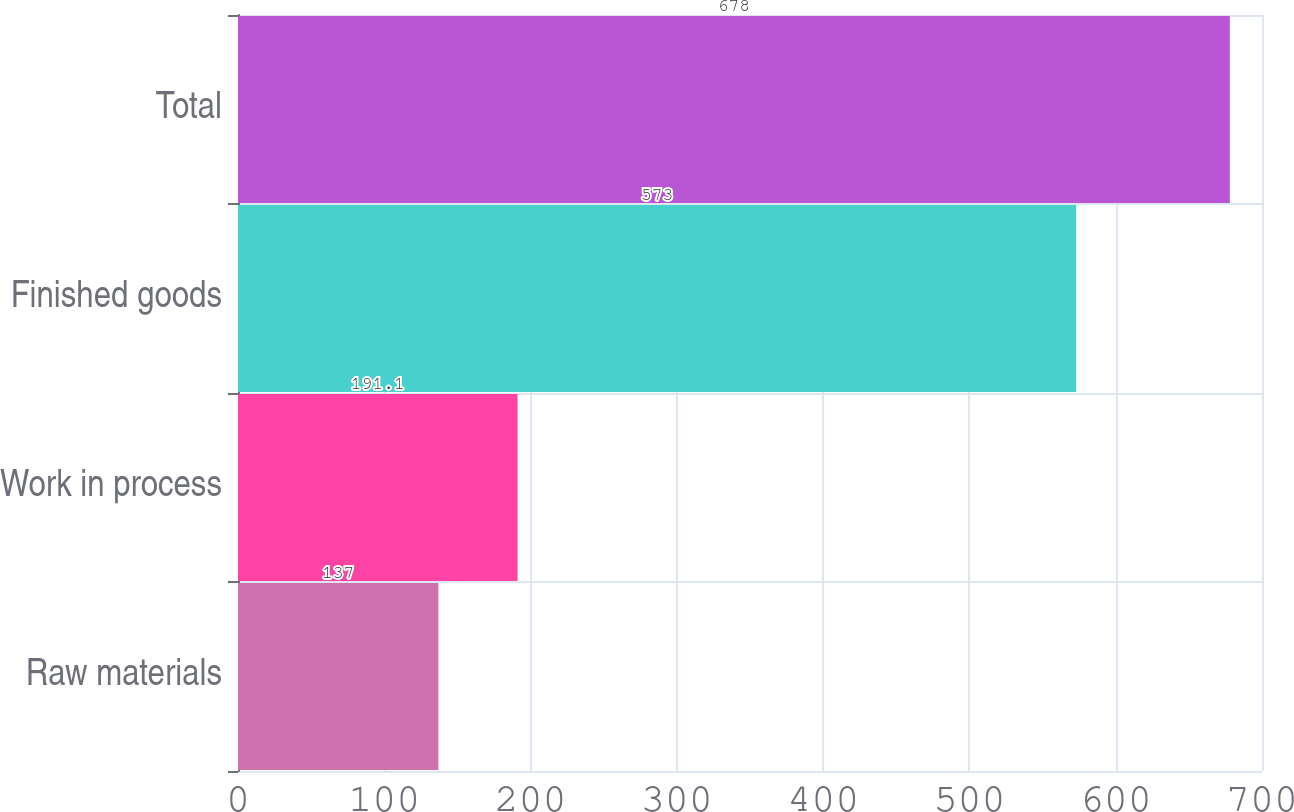<chart> <loc_0><loc_0><loc_500><loc_500><bar_chart><fcel>Raw materials<fcel>Work in process<fcel>Finished goods<fcel>Total<nl><fcel>137<fcel>191.1<fcel>573<fcel>678<nl></chart> 